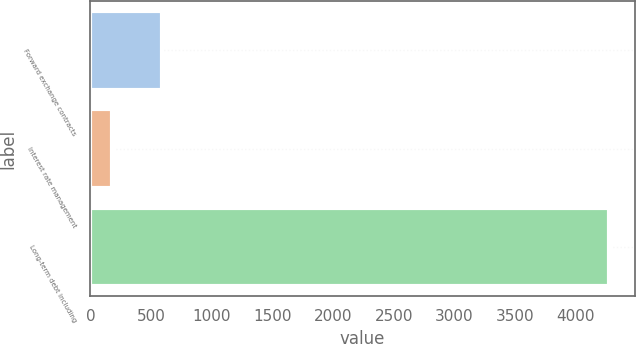Convert chart. <chart><loc_0><loc_0><loc_500><loc_500><bar_chart><fcel>Forward exchange contracts<fcel>Interest rate management<fcel>Long-term debt including<nl><fcel>589.42<fcel>179.9<fcel>4275.1<nl></chart> 